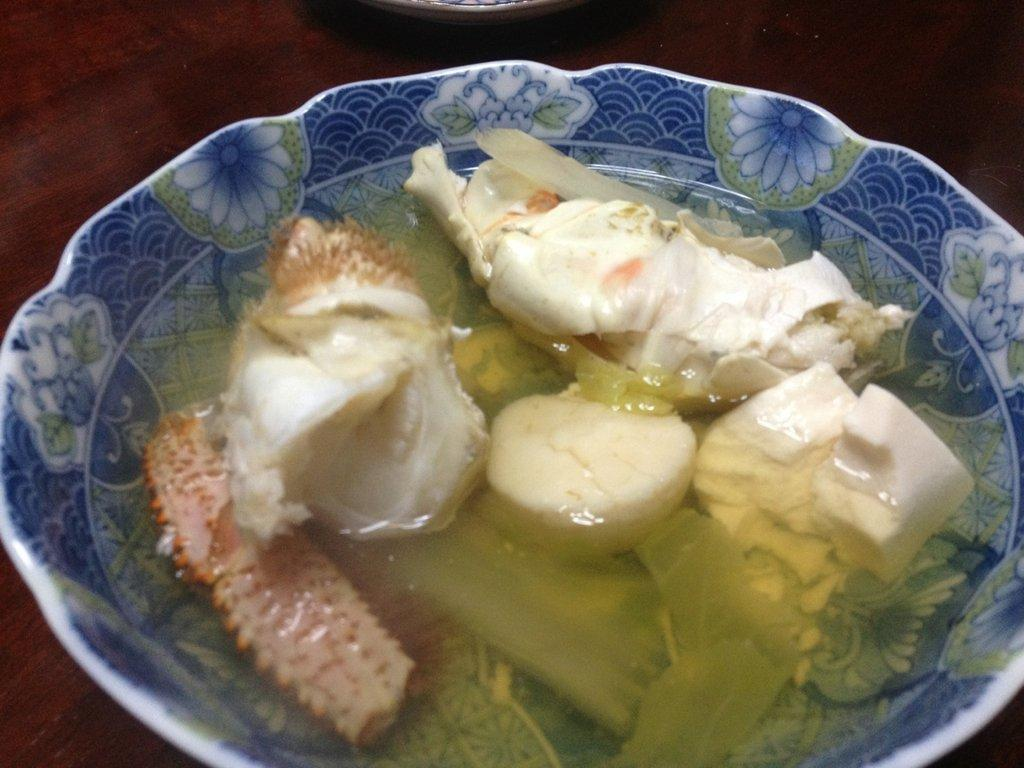What is in the bowl that is visible in the image? There are veggies in the bowl. What else is in the bowl besides the veggies? There is water in the bowl. Can you describe the background of the image? There appears to be a table in the background of the image. What type of door can be seen in the image? There is no door present in the image; it features a bowl of veggies and water with a table in the background. 